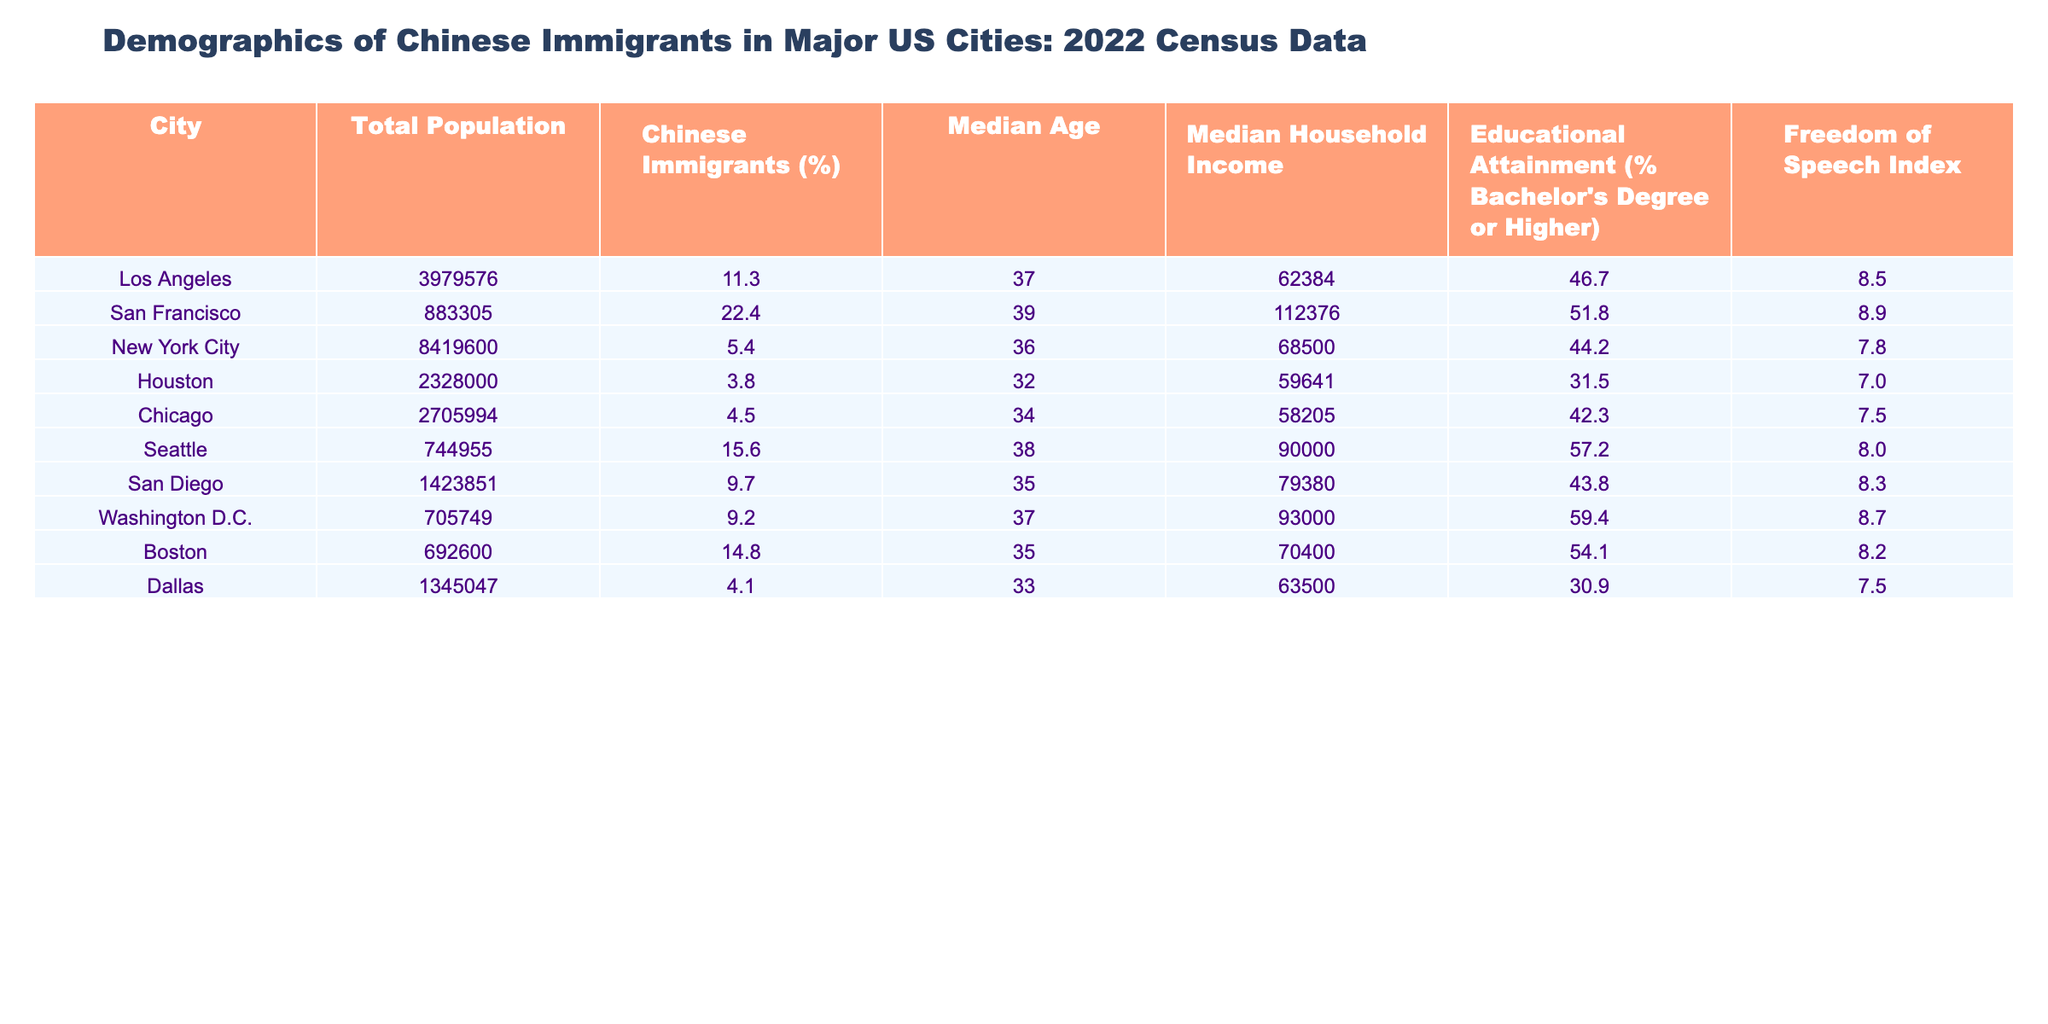What is the median household income of San Francisco? According to the table, the median household income is located in the "Median Household Income" column corresponding to San Francisco's row. It shows $112376.
Answer: $112376 Which city has the highest percentage of Chinese immigrants? By examining the "Chinese Immigrants (%)" column, San Francisco has a value of 22.4%, which is the highest among all cities listed.
Answer: San Francisco What is the median age of Los Angeles? The median age can be found in the "Median Age" column corresponding to Los Angeles. The value listed is 37.
Answer: 37 Which city has the lowest median household income among the cities listed? By checking the "Median Household Income" column, we find that Houston has the lowest value at $59641.
Answer: Houston What is the average percentage of bachelor's degree holders among the cities listed? To find the average, sum the percentages in the "Educational Attainment (% Bachelor's Degree or Higher)" column: (46.7 + 51.8 + 44.2 + 31.5 + 42.3 + 57.2 + 43.8 + 59.4 + 54.1 + 30.9) = 462.9. Dividing by 10 cities gives 462.9 / 10 = 46.29%.
Answer: 46.29% Do more than half of the residents in Seattle hold a bachelor's degree or higher? In the "Educational Attainment" column for Seattle, it shows 57.2%. Since this is greater than 50%, the answer is yes.
Answer: Yes Which city has the highest Freedom of Speech Index? Looking at the "Freedom of Speech Index" column, San Francisco shows the highest value of 8.9, indicating it has the highest index.
Answer: San Francisco What is the difference in median age between New York City and Houston? The median age for New York City is 36 and for Houston is 32. The difference is 36 - 32 = 4 years.
Answer: 4 years Does Washington D.C. have a higher Freedom of Speech Index compared to Los Angeles? The index for Washington D.C. is 8.7 while for Los Angeles, it is 8.5. Since 8.7 is greater than 8.5, the answer is yes.
Answer: Yes How many cities have a median household income greater than $80,000? By checking the "Median Household Income" column, the cities with incomes above $80,000 are San Francisco ($112376), Seattle ($90000), and Washington D.C. ($93000). This totals 3 cities.
Answer: 3 cities Which city has the lowest percentage of bachelor's degree holders? In the "Educational Attainment (%)" column, Houston shows the lowest percentage at 31.5%.
Answer: Houston 